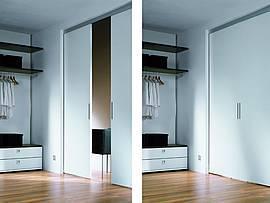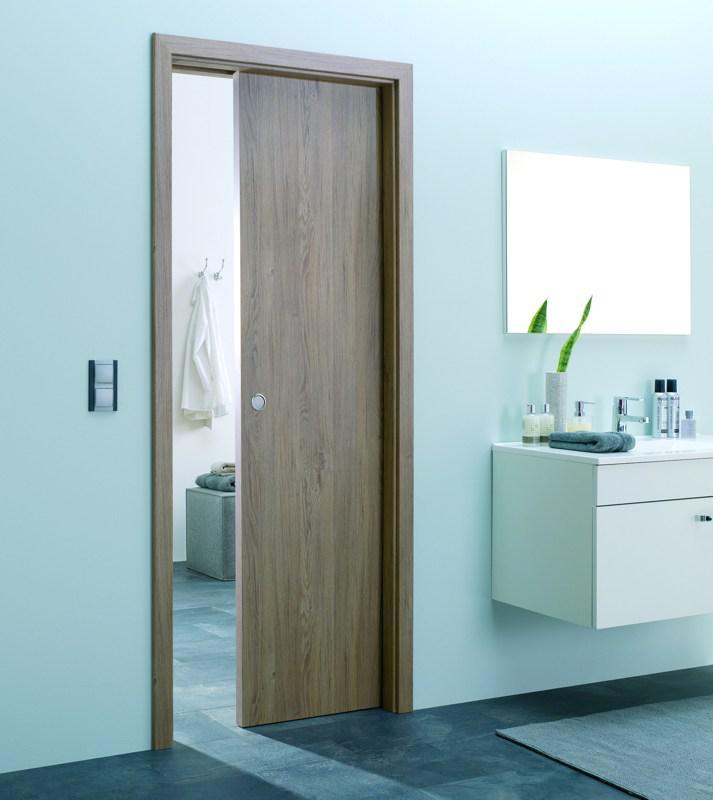The first image is the image on the left, the second image is the image on the right. Considering the images on both sides, is "One door is mirrored." valid? Answer yes or no. No. The first image is the image on the left, the second image is the image on the right. Assess this claim about the two images: "There is a two door closet closed with the front being white with light line to create eight rectangles.". Correct or not? Answer yes or no. No. 